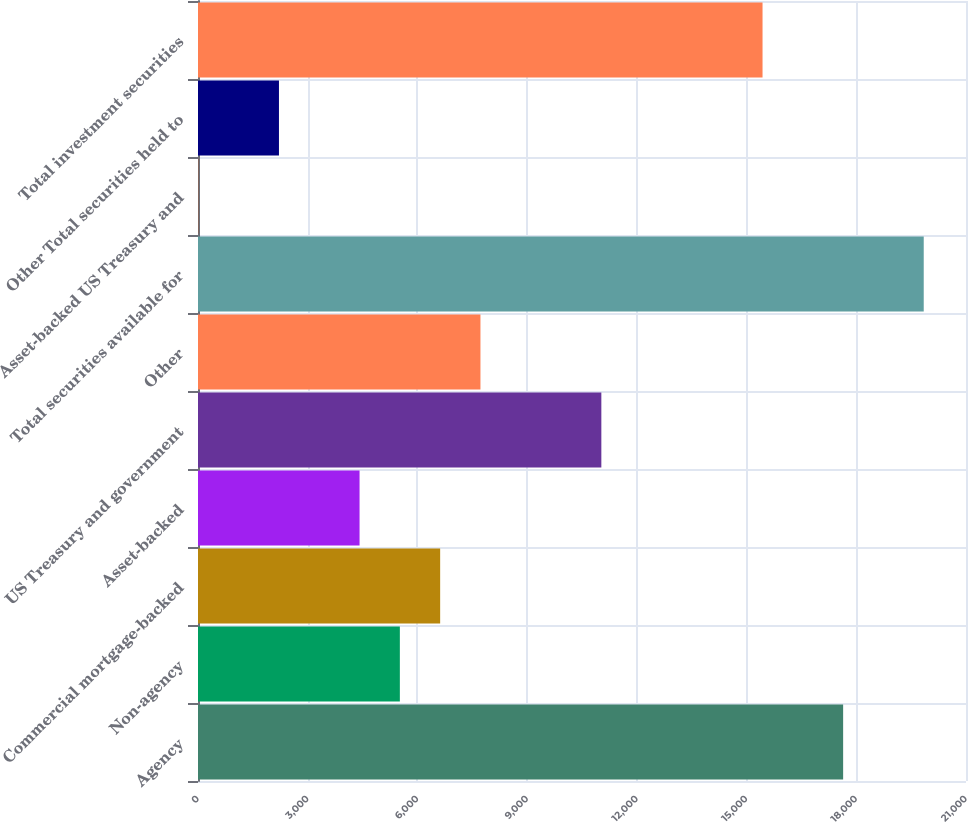Convert chart. <chart><loc_0><loc_0><loc_500><loc_500><bar_chart><fcel>Agency<fcel>Non-agency<fcel>Commercial mortgage-backed<fcel>Asset-backed<fcel>US Treasury and government<fcel>Other<fcel>Total securities available for<fcel>Asset-backed US Treasury and<fcel>Other Total securities held to<fcel>Total investment securities<nl><fcel>17640.4<fcel>5519.5<fcel>6621.4<fcel>4417.6<fcel>11029<fcel>7723.3<fcel>19844.2<fcel>10<fcel>2213.8<fcel>15436.6<nl></chart> 